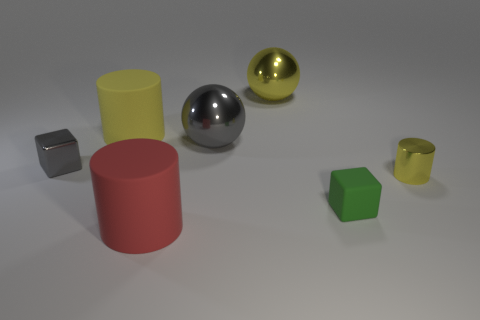What number of yellow objects are there?
Ensure brevity in your answer.  3. What is the color of the other block that is the same size as the green matte block?
Give a very brief answer. Gray. Is the red cylinder the same size as the yellow rubber cylinder?
Offer a very short reply. Yes. There is a metal thing that is the same color as the shiny cylinder; what is its shape?
Provide a succinct answer. Sphere. Is the size of the red thing the same as the yellow shiny thing that is on the left side of the green object?
Offer a terse response. Yes. What color is the small object that is both behind the rubber block and to the right of the yellow ball?
Make the answer very short. Yellow. Is the number of tiny yellow cylinders on the left side of the large yellow rubber cylinder greater than the number of big yellow balls that are left of the gray metal ball?
Your answer should be compact. No. There is a yellow cylinder that is made of the same material as the red object; what size is it?
Provide a short and direct response. Large. There is a cylinder to the right of the red matte thing; how many small yellow shiny objects are in front of it?
Ensure brevity in your answer.  0. Are there any big yellow objects of the same shape as the tiny yellow object?
Your answer should be compact. Yes. 